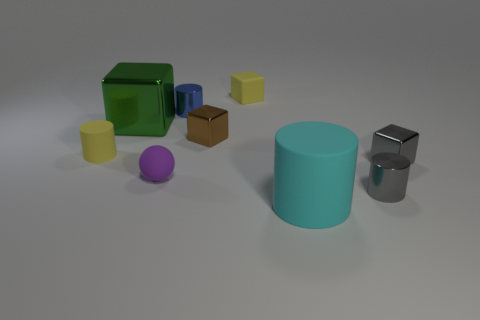Add 1 large objects. How many objects exist? 10 Subtract all cylinders. How many objects are left? 5 Subtract all tiny brown things. Subtract all cyan objects. How many objects are left? 7 Add 9 big blocks. How many big blocks are left? 10 Add 3 tiny cyan rubber spheres. How many tiny cyan rubber spheres exist? 3 Subtract 1 brown cubes. How many objects are left? 8 